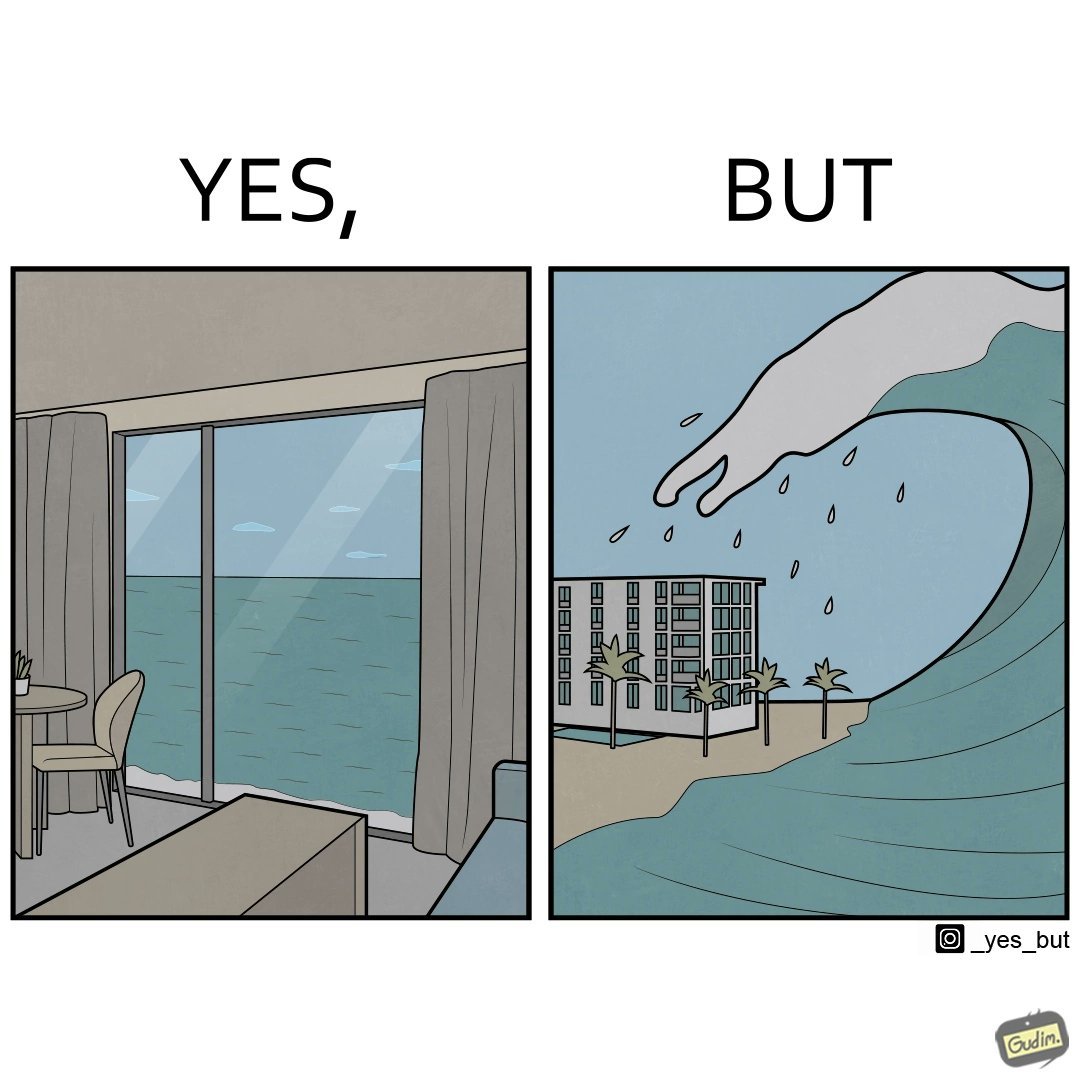Why is this image considered satirical? The same sea which gives us a relaxation on a normal day can pose a danger to us sometimes like during a tsunami 